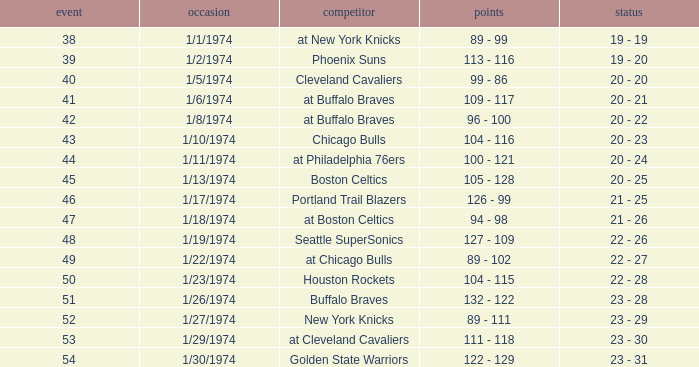What was the score on 1/10/1974? 104 - 116. 